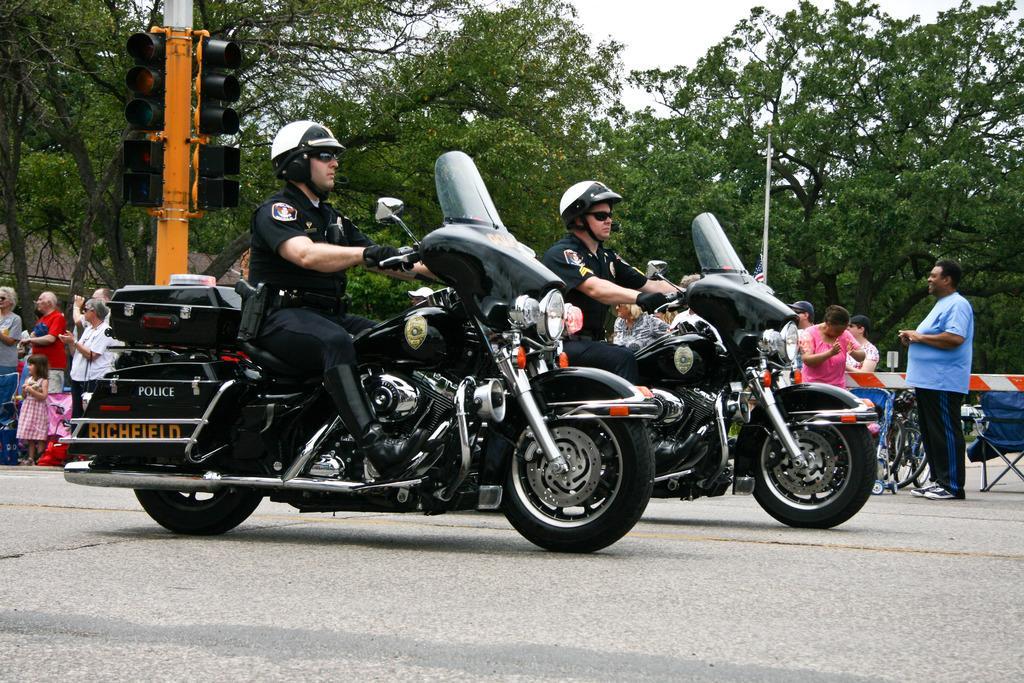Can you describe this image briefly? In this picture we can see two persons wore helmet, goggles, gloves riding bikes and in background we can see traffic light, tree, sky, pole, flag, some person standing. 